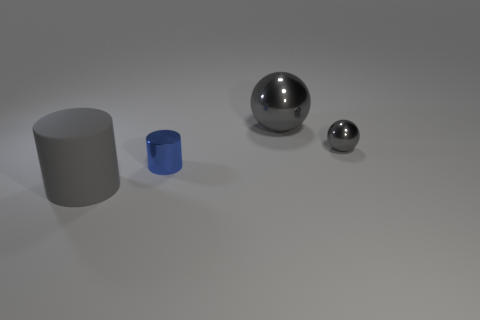Can you tell me the relative sizes of the objects in the image? Certainly! From largest to smallest, we have a gray cylindrical object, a large sphere, a smaller blue cylinder, and the smallest object is a tiny gray sphere. 